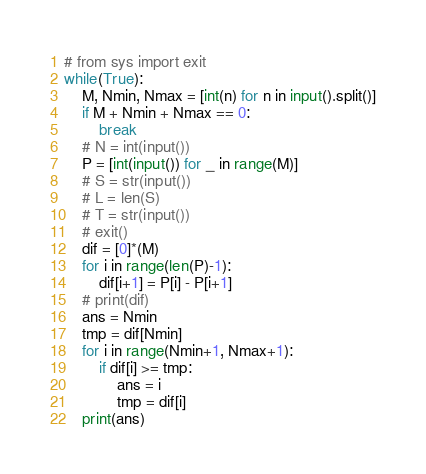<code> <loc_0><loc_0><loc_500><loc_500><_Python_># from sys import exit
while(True):
    M, Nmin, Nmax = [int(n) for n in input().split()]
    if M + Nmin + Nmax == 0:
        break
    # N = int(input())
    P = [int(input()) for _ in range(M)]
    # S = str(input())
    # L = len(S)
    # T = str(input())
    # exit()
    dif = [0]*(M)
    for i in range(len(P)-1):
        dif[i+1] = P[i] - P[i+1]
    # print(dif)
    ans = Nmin
    tmp = dif[Nmin]
    for i in range(Nmin+1, Nmax+1):
        if dif[i] >= tmp:
            ans = i
            tmp = dif[i]
    print(ans)

</code> 